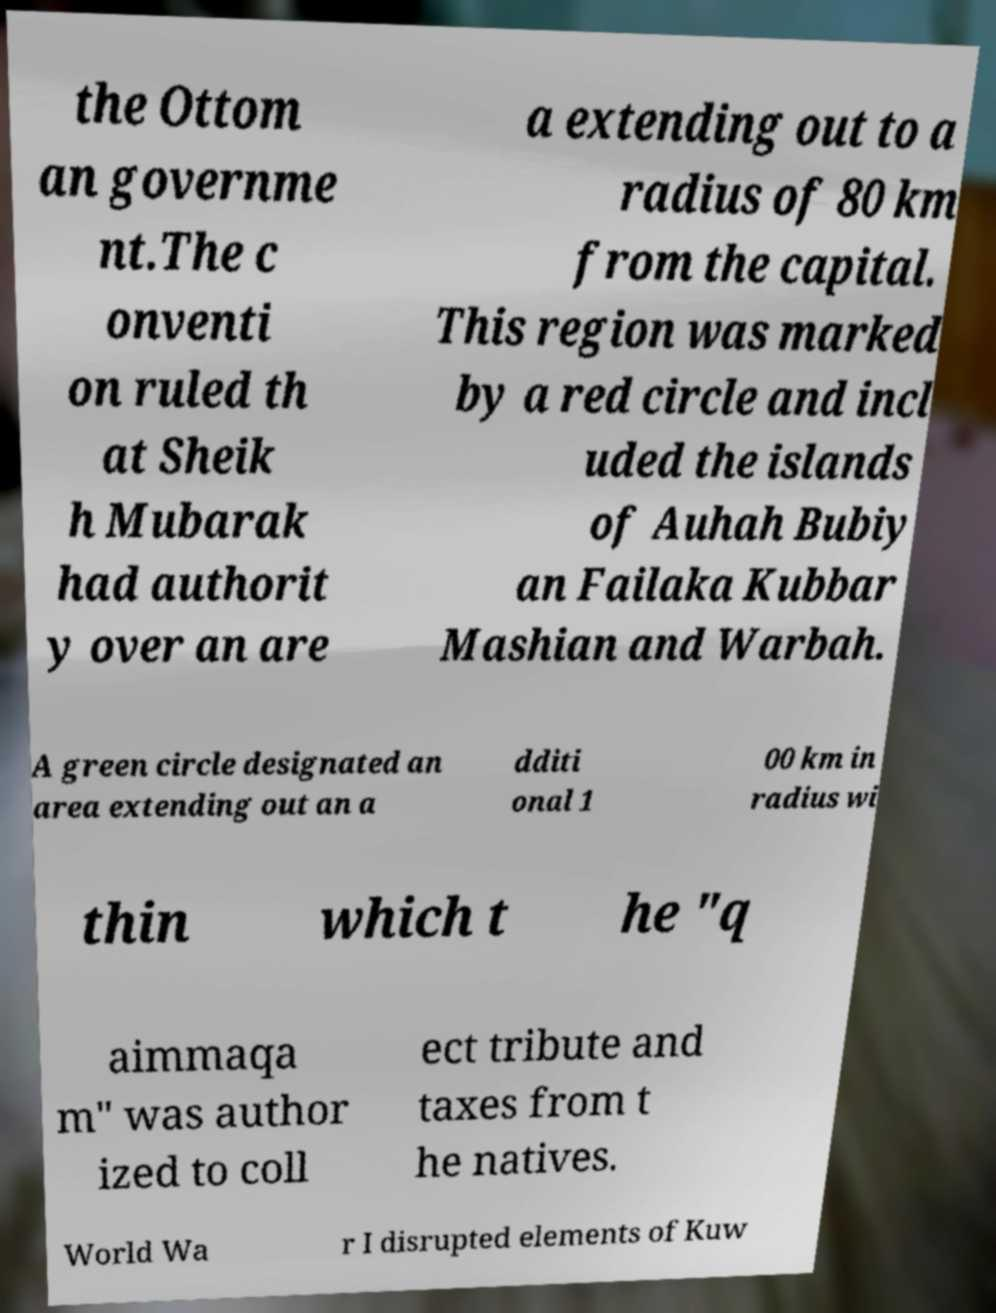For documentation purposes, I need the text within this image transcribed. Could you provide that? the Ottom an governme nt.The c onventi on ruled th at Sheik h Mubarak had authorit y over an are a extending out to a radius of 80 km from the capital. This region was marked by a red circle and incl uded the islands of Auhah Bubiy an Failaka Kubbar Mashian and Warbah. A green circle designated an area extending out an a dditi onal 1 00 km in radius wi thin which t he "q aimmaqa m" was author ized to coll ect tribute and taxes from t he natives. World Wa r I disrupted elements of Kuw 